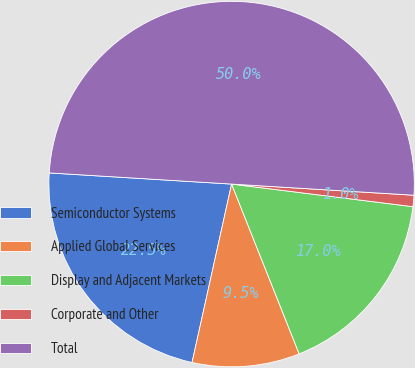<chart> <loc_0><loc_0><loc_500><loc_500><pie_chart><fcel>Semiconductor Systems<fcel>Applied Global Services<fcel>Display and Adjacent Markets<fcel>Corporate and Other<fcel>Total<nl><fcel>22.5%<fcel>9.5%<fcel>17.0%<fcel>1.0%<fcel>50.0%<nl></chart> 